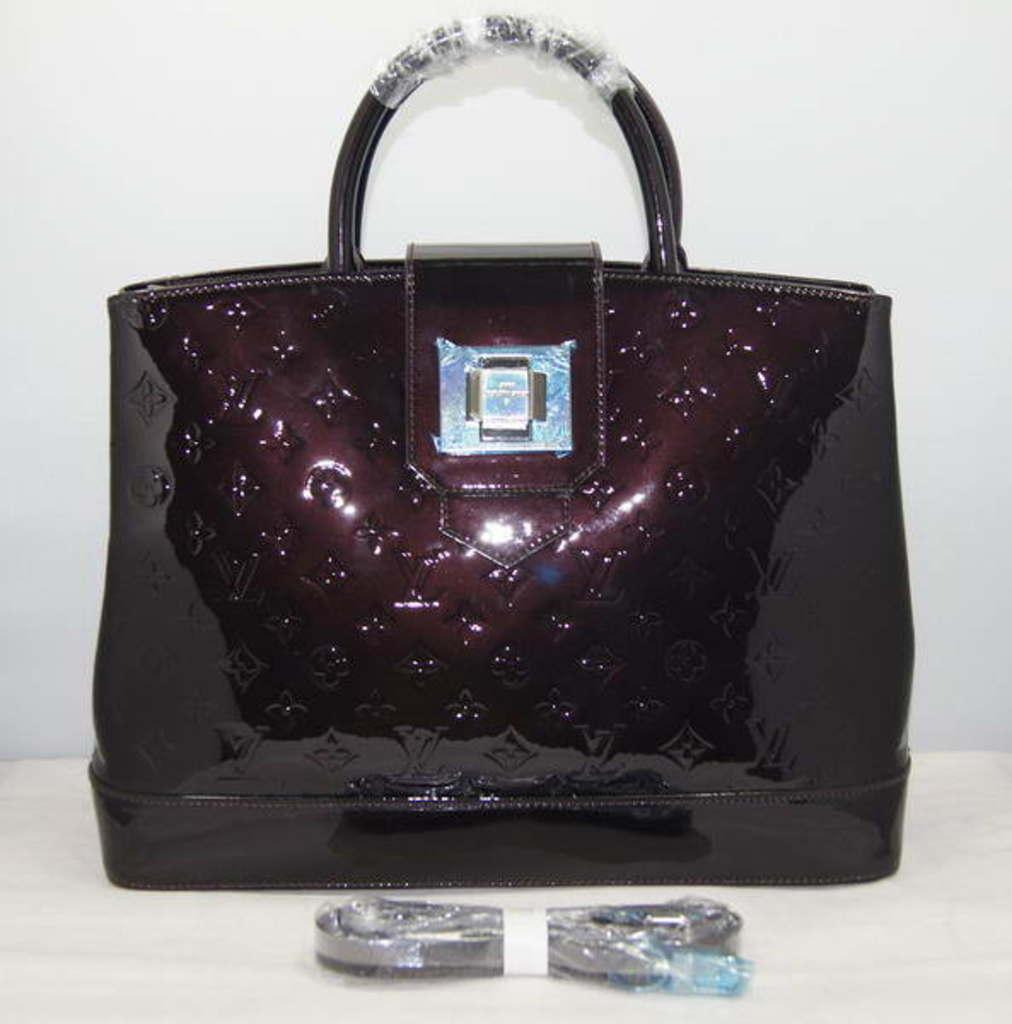What type of object is visible in the image with a handle? There is a bag with a handle in the image. Where is the bag located in the image? The bag is on a table. What else can be seen on the table besides the bag? There are other items on the table. What type of flower is present on the table in the image? There is no flower present on the table in the image. What activity is taking place in the image? The image does not depict any specific activity; it simply shows a bag with a handle on a table with other items. 